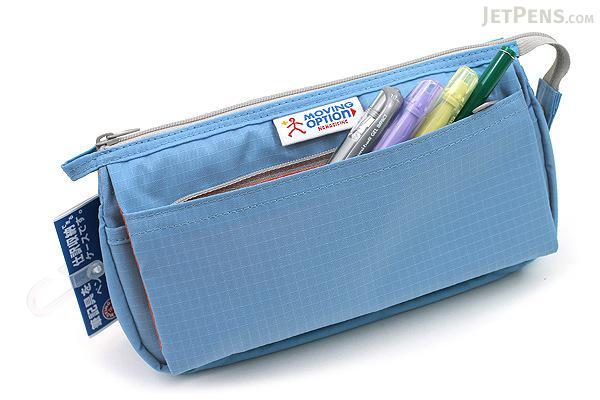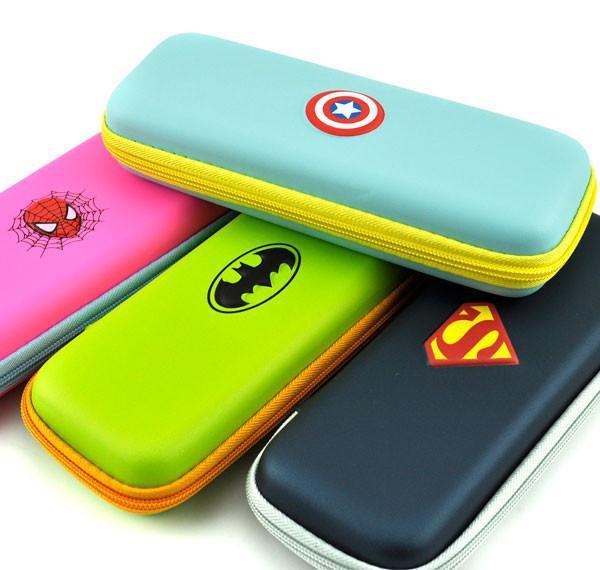The first image is the image on the left, the second image is the image on the right. Examine the images to the left and right. Is the description "There is a single oblong, black rectangular case with no visible logo on it." accurate? Answer yes or no. No. The first image is the image on the left, the second image is the image on the right. Analyze the images presented: Is the assertion "An image shows just one pencil case, and it is solid sky blue in color." valid? Answer yes or no. Yes. 